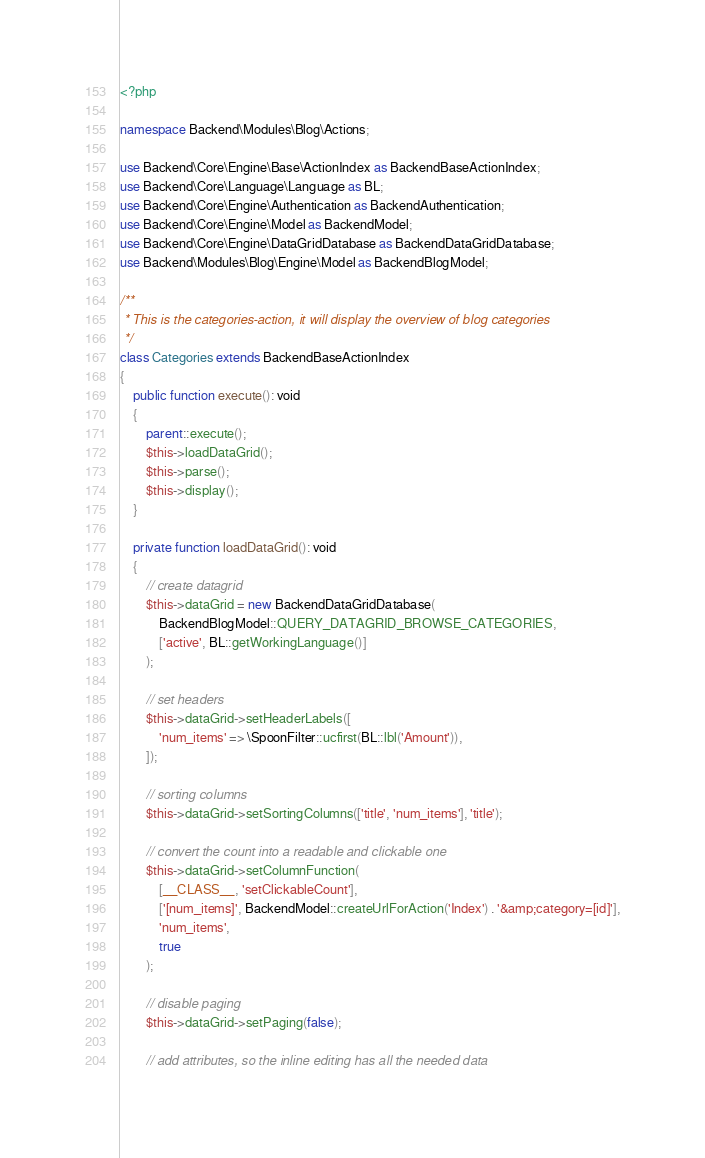<code> <loc_0><loc_0><loc_500><loc_500><_PHP_><?php

namespace Backend\Modules\Blog\Actions;

use Backend\Core\Engine\Base\ActionIndex as BackendBaseActionIndex;
use Backend\Core\Language\Language as BL;
use Backend\Core\Engine\Authentication as BackendAuthentication;
use Backend\Core\Engine\Model as BackendModel;
use Backend\Core\Engine\DataGridDatabase as BackendDataGridDatabase;
use Backend\Modules\Blog\Engine\Model as BackendBlogModel;

/**
 * This is the categories-action, it will display the overview of blog categories
 */
class Categories extends BackendBaseActionIndex
{
    public function execute(): void
    {
        parent::execute();
        $this->loadDataGrid();
        $this->parse();
        $this->display();
    }

    private function loadDataGrid(): void
    {
        // create datagrid
        $this->dataGrid = new BackendDataGridDatabase(
            BackendBlogModel::QUERY_DATAGRID_BROWSE_CATEGORIES,
            ['active', BL::getWorkingLanguage()]
        );

        // set headers
        $this->dataGrid->setHeaderLabels([
            'num_items' => \SpoonFilter::ucfirst(BL::lbl('Amount')),
        ]);

        // sorting columns
        $this->dataGrid->setSortingColumns(['title', 'num_items'], 'title');

        // convert the count into a readable and clickable one
        $this->dataGrid->setColumnFunction(
            [__CLASS__, 'setClickableCount'],
            ['[num_items]', BackendModel::createUrlForAction('Index') . '&amp;category=[id]'],
            'num_items',
            true
        );

        // disable paging
        $this->dataGrid->setPaging(false);

        // add attributes, so the inline editing has all the needed data</code> 